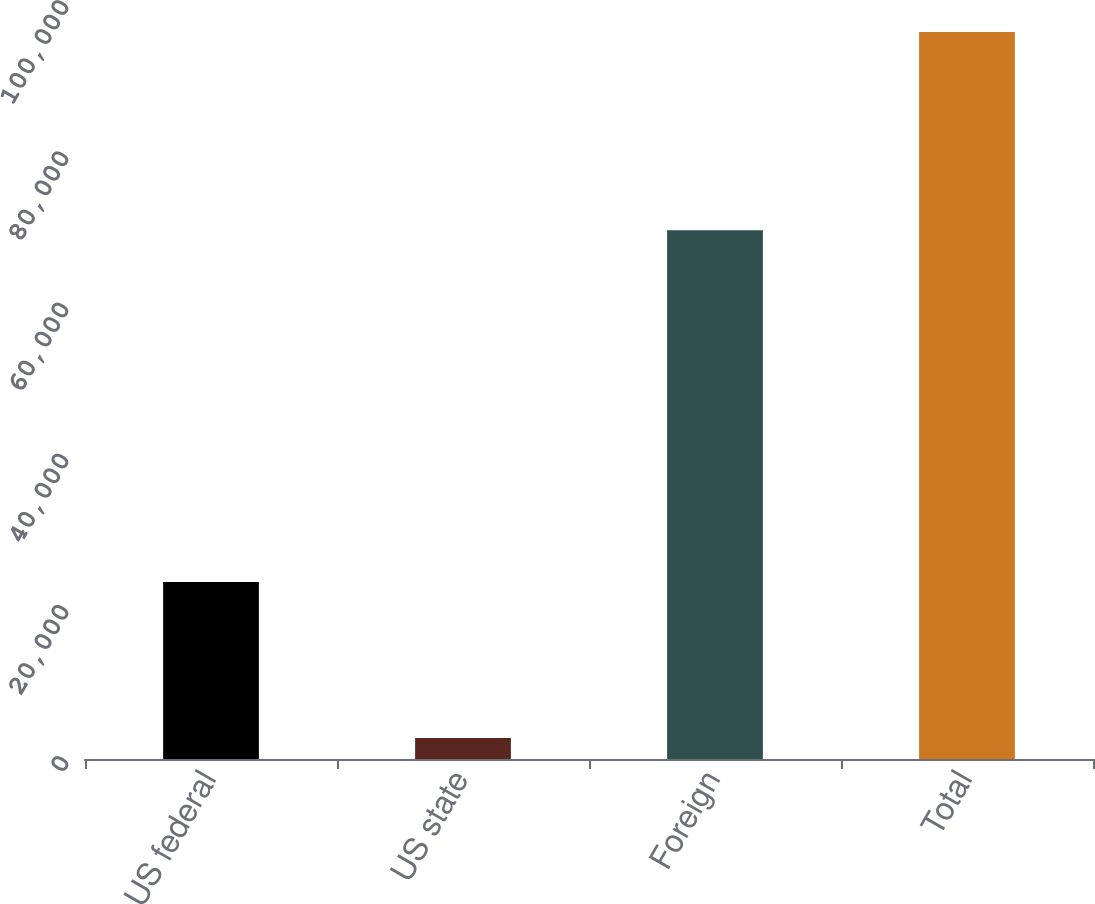<chart> <loc_0><loc_0><loc_500><loc_500><bar_chart><fcel>US federal<fcel>US state<fcel>Foreign<fcel>Total<nl><fcel>23412<fcel>2788<fcel>69954<fcel>96154<nl></chart> 